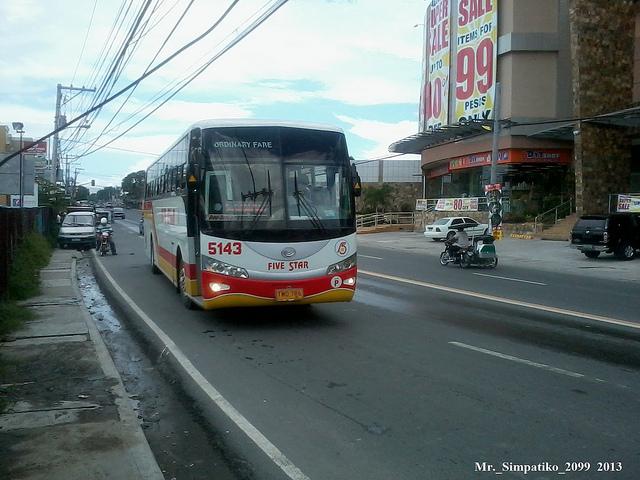What country is this bus in?
Keep it brief. America. What vehicle is behind the bus?
Concise answer only. Motorcycle. What number is on the bus?
Answer briefly. 5143. Are the signs in English?
Concise answer only. Yes. Who own's the picture?
Answer briefly. Mr simpatiko. What number is written in front of the bus?
Quick response, please. 5143. 